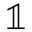<formula> <loc_0><loc_0><loc_500><loc_500>\mathbb { 1 }</formula> 